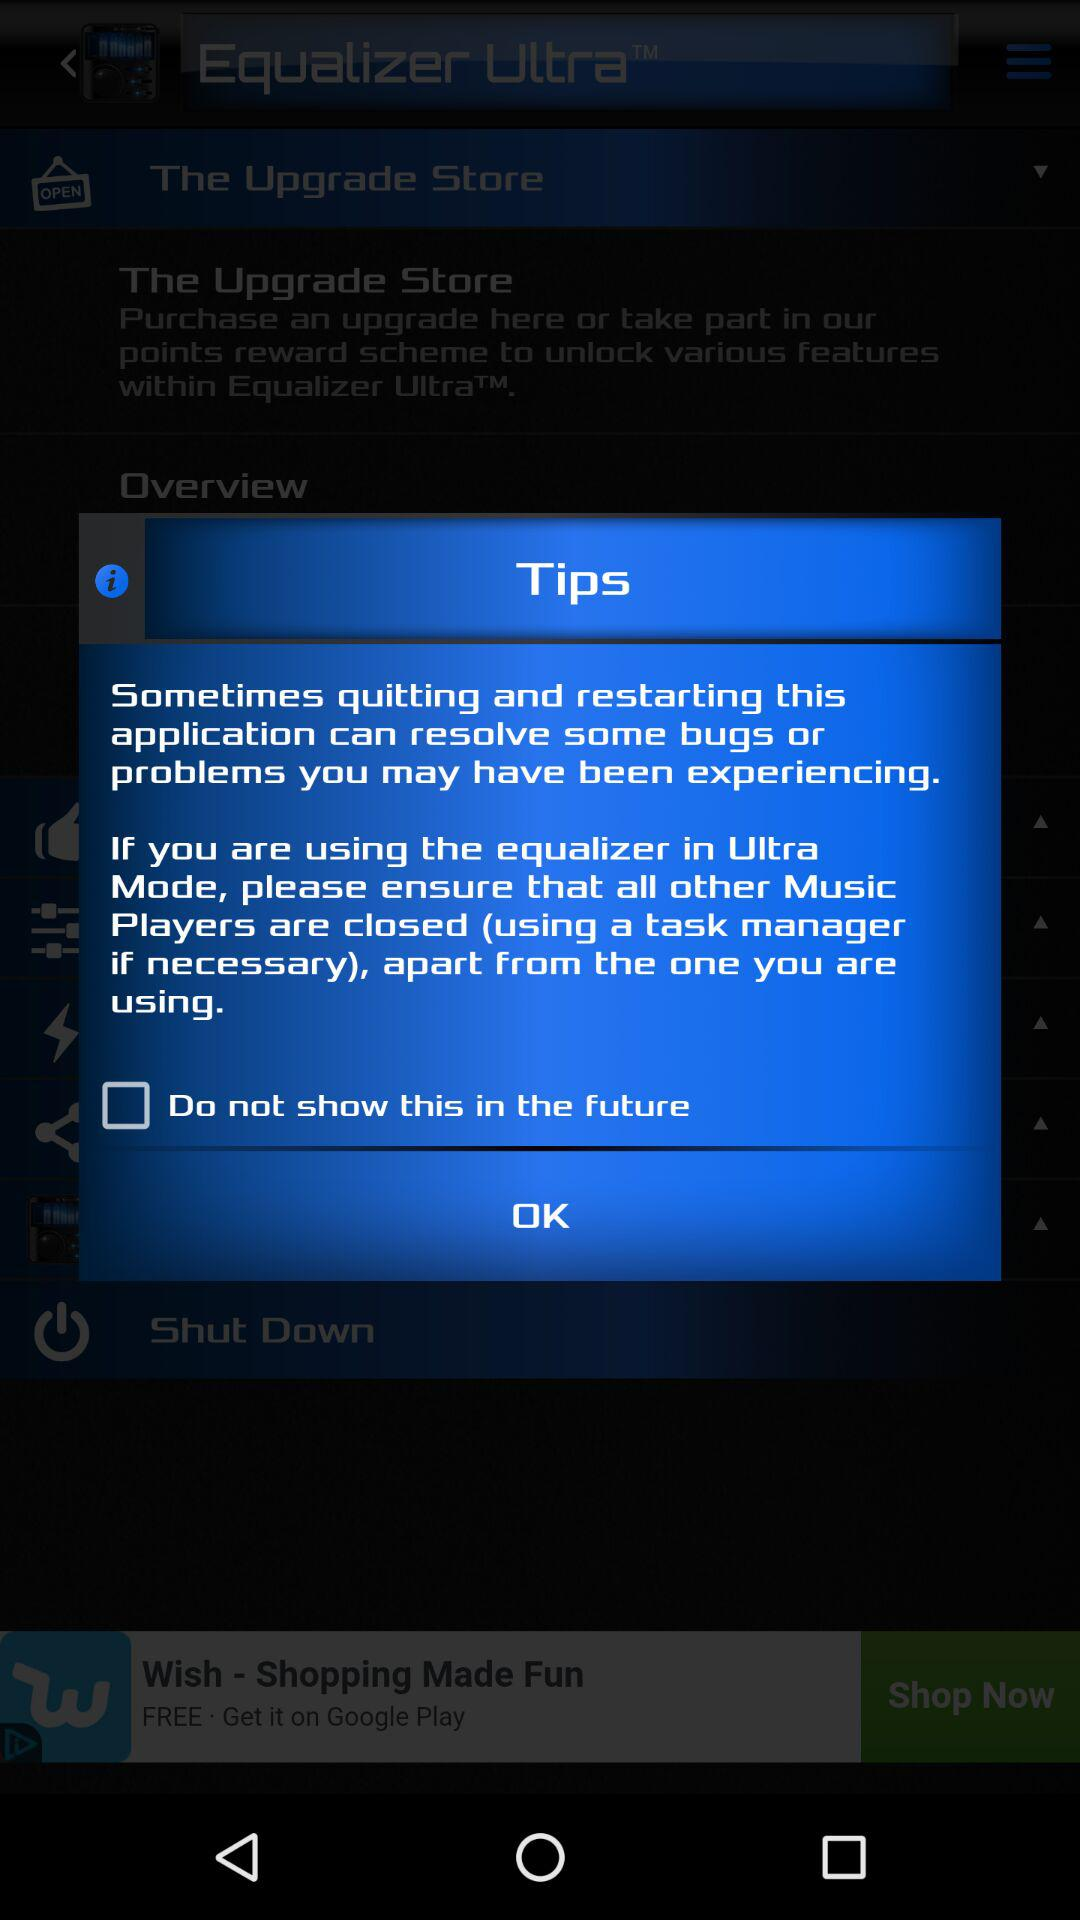What is the status of "Do not show this in the future"? The status is "off". 